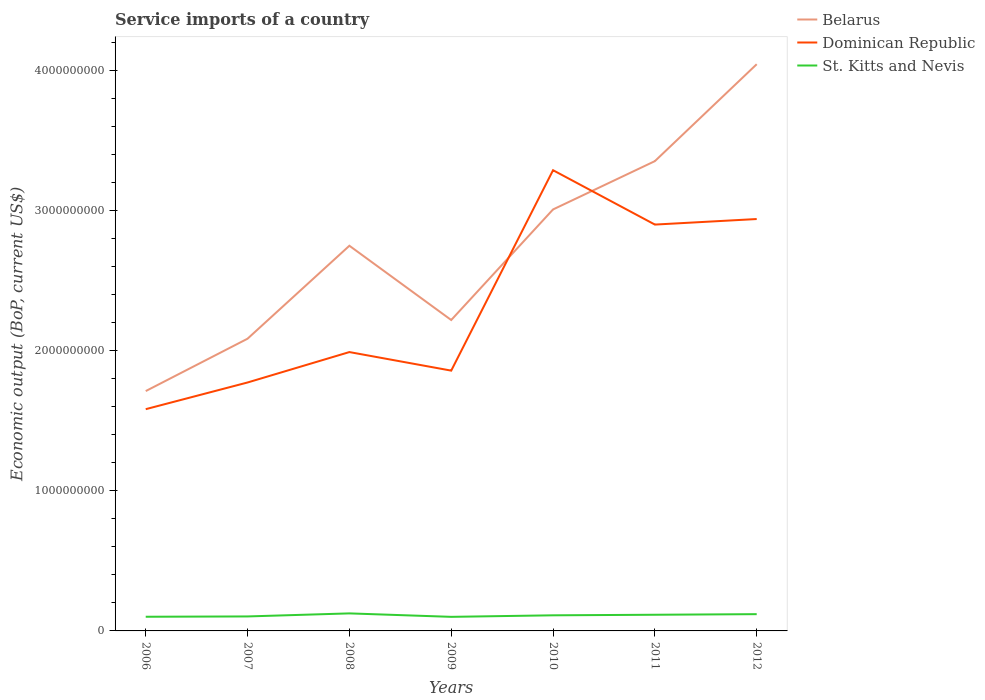How many different coloured lines are there?
Keep it short and to the point. 3. Across all years, what is the maximum service imports in St. Kitts and Nevis?
Your answer should be compact. 1.00e+08. What is the total service imports in St. Kitts and Nevis in the graph?
Ensure brevity in your answer.  -1.85e+07. What is the difference between the highest and the second highest service imports in Belarus?
Your answer should be compact. 2.33e+09. How many lines are there?
Give a very brief answer. 3. How many years are there in the graph?
Your response must be concise. 7. Are the values on the major ticks of Y-axis written in scientific E-notation?
Provide a succinct answer. No. How many legend labels are there?
Ensure brevity in your answer.  3. What is the title of the graph?
Your response must be concise. Service imports of a country. What is the label or title of the X-axis?
Give a very brief answer. Years. What is the label or title of the Y-axis?
Keep it short and to the point. Economic output (BoP, current US$). What is the Economic output (BoP, current US$) of Belarus in 2006?
Make the answer very short. 1.71e+09. What is the Economic output (BoP, current US$) of Dominican Republic in 2006?
Offer a very short reply. 1.58e+09. What is the Economic output (BoP, current US$) in St. Kitts and Nevis in 2006?
Your response must be concise. 1.01e+08. What is the Economic output (BoP, current US$) in Belarus in 2007?
Offer a very short reply. 2.08e+09. What is the Economic output (BoP, current US$) in Dominican Republic in 2007?
Provide a succinct answer. 1.77e+09. What is the Economic output (BoP, current US$) of St. Kitts and Nevis in 2007?
Give a very brief answer. 1.03e+08. What is the Economic output (BoP, current US$) in Belarus in 2008?
Keep it short and to the point. 2.75e+09. What is the Economic output (BoP, current US$) in Dominican Republic in 2008?
Make the answer very short. 1.99e+09. What is the Economic output (BoP, current US$) of St. Kitts and Nevis in 2008?
Ensure brevity in your answer.  1.25e+08. What is the Economic output (BoP, current US$) of Belarus in 2009?
Offer a very short reply. 2.22e+09. What is the Economic output (BoP, current US$) of Dominican Republic in 2009?
Offer a very short reply. 1.86e+09. What is the Economic output (BoP, current US$) in St. Kitts and Nevis in 2009?
Your answer should be compact. 1.00e+08. What is the Economic output (BoP, current US$) in Belarus in 2010?
Provide a short and direct response. 3.01e+09. What is the Economic output (BoP, current US$) in Dominican Republic in 2010?
Your response must be concise. 3.29e+09. What is the Economic output (BoP, current US$) in St. Kitts and Nevis in 2010?
Offer a very short reply. 1.11e+08. What is the Economic output (BoP, current US$) of Belarus in 2011?
Ensure brevity in your answer.  3.35e+09. What is the Economic output (BoP, current US$) of Dominican Republic in 2011?
Offer a very short reply. 2.90e+09. What is the Economic output (BoP, current US$) of St. Kitts and Nevis in 2011?
Your answer should be very brief. 1.15e+08. What is the Economic output (BoP, current US$) in Belarus in 2012?
Provide a succinct answer. 4.04e+09. What is the Economic output (BoP, current US$) in Dominican Republic in 2012?
Make the answer very short. 2.94e+09. What is the Economic output (BoP, current US$) in St. Kitts and Nevis in 2012?
Provide a short and direct response. 1.20e+08. Across all years, what is the maximum Economic output (BoP, current US$) in Belarus?
Your answer should be compact. 4.04e+09. Across all years, what is the maximum Economic output (BoP, current US$) in Dominican Republic?
Your answer should be compact. 3.29e+09. Across all years, what is the maximum Economic output (BoP, current US$) in St. Kitts and Nevis?
Ensure brevity in your answer.  1.25e+08. Across all years, what is the minimum Economic output (BoP, current US$) of Belarus?
Your response must be concise. 1.71e+09. Across all years, what is the minimum Economic output (BoP, current US$) of Dominican Republic?
Ensure brevity in your answer.  1.58e+09. Across all years, what is the minimum Economic output (BoP, current US$) of St. Kitts and Nevis?
Give a very brief answer. 1.00e+08. What is the total Economic output (BoP, current US$) in Belarus in the graph?
Provide a succinct answer. 1.92e+1. What is the total Economic output (BoP, current US$) of Dominican Republic in the graph?
Provide a short and direct response. 1.63e+1. What is the total Economic output (BoP, current US$) of St. Kitts and Nevis in the graph?
Your answer should be very brief. 7.76e+08. What is the difference between the Economic output (BoP, current US$) in Belarus in 2006 and that in 2007?
Offer a terse response. -3.74e+08. What is the difference between the Economic output (BoP, current US$) of Dominican Republic in 2006 and that in 2007?
Your response must be concise. -1.90e+08. What is the difference between the Economic output (BoP, current US$) of St. Kitts and Nevis in 2006 and that in 2007?
Your response must be concise. -2.25e+06. What is the difference between the Economic output (BoP, current US$) of Belarus in 2006 and that in 2008?
Provide a succinct answer. -1.04e+09. What is the difference between the Economic output (BoP, current US$) in Dominican Republic in 2006 and that in 2008?
Ensure brevity in your answer.  -4.07e+08. What is the difference between the Economic output (BoP, current US$) of St. Kitts and Nevis in 2006 and that in 2008?
Your answer should be very brief. -2.40e+07. What is the difference between the Economic output (BoP, current US$) of Belarus in 2006 and that in 2009?
Provide a succinct answer. -5.07e+08. What is the difference between the Economic output (BoP, current US$) in Dominican Republic in 2006 and that in 2009?
Offer a terse response. -2.75e+08. What is the difference between the Economic output (BoP, current US$) of St. Kitts and Nevis in 2006 and that in 2009?
Make the answer very short. 6.64e+05. What is the difference between the Economic output (BoP, current US$) of Belarus in 2006 and that in 2010?
Your answer should be compact. -1.30e+09. What is the difference between the Economic output (BoP, current US$) in Dominican Republic in 2006 and that in 2010?
Your answer should be compact. -1.70e+09. What is the difference between the Economic output (BoP, current US$) in St. Kitts and Nevis in 2006 and that in 2010?
Your response must be concise. -1.03e+07. What is the difference between the Economic output (BoP, current US$) of Belarus in 2006 and that in 2011?
Ensure brevity in your answer.  -1.64e+09. What is the difference between the Economic output (BoP, current US$) of Dominican Republic in 2006 and that in 2011?
Your response must be concise. -1.32e+09. What is the difference between the Economic output (BoP, current US$) of St. Kitts and Nevis in 2006 and that in 2011?
Ensure brevity in your answer.  -1.42e+07. What is the difference between the Economic output (BoP, current US$) in Belarus in 2006 and that in 2012?
Provide a short and direct response. -2.33e+09. What is the difference between the Economic output (BoP, current US$) of Dominican Republic in 2006 and that in 2012?
Offer a very short reply. -1.36e+09. What is the difference between the Economic output (BoP, current US$) in St. Kitts and Nevis in 2006 and that in 2012?
Give a very brief answer. -1.85e+07. What is the difference between the Economic output (BoP, current US$) in Belarus in 2007 and that in 2008?
Your response must be concise. -6.63e+08. What is the difference between the Economic output (BoP, current US$) in Dominican Republic in 2007 and that in 2008?
Your answer should be compact. -2.17e+08. What is the difference between the Economic output (BoP, current US$) of St. Kitts and Nevis in 2007 and that in 2008?
Keep it short and to the point. -2.17e+07. What is the difference between the Economic output (BoP, current US$) of Belarus in 2007 and that in 2009?
Your answer should be compact. -1.33e+08. What is the difference between the Economic output (BoP, current US$) in Dominican Republic in 2007 and that in 2009?
Provide a succinct answer. -8.46e+07. What is the difference between the Economic output (BoP, current US$) of St. Kitts and Nevis in 2007 and that in 2009?
Offer a very short reply. 2.91e+06. What is the difference between the Economic output (BoP, current US$) in Belarus in 2007 and that in 2010?
Ensure brevity in your answer.  -9.22e+08. What is the difference between the Economic output (BoP, current US$) in Dominican Republic in 2007 and that in 2010?
Provide a succinct answer. -1.51e+09. What is the difference between the Economic output (BoP, current US$) in St. Kitts and Nevis in 2007 and that in 2010?
Make the answer very short. -8.01e+06. What is the difference between the Economic output (BoP, current US$) in Belarus in 2007 and that in 2011?
Your answer should be compact. -1.27e+09. What is the difference between the Economic output (BoP, current US$) in Dominican Republic in 2007 and that in 2011?
Keep it short and to the point. -1.13e+09. What is the difference between the Economic output (BoP, current US$) of St. Kitts and Nevis in 2007 and that in 2011?
Ensure brevity in your answer.  -1.20e+07. What is the difference between the Economic output (BoP, current US$) in Belarus in 2007 and that in 2012?
Keep it short and to the point. -1.96e+09. What is the difference between the Economic output (BoP, current US$) of Dominican Republic in 2007 and that in 2012?
Keep it short and to the point. -1.17e+09. What is the difference between the Economic output (BoP, current US$) in St. Kitts and Nevis in 2007 and that in 2012?
Your answer should be compact. -1.62e+07. What is the difference between the Economic output (BoP, current US$) in Belarus in 2008 and that in 2009?
Provide a succinct answer. 5.30e+08. What is the difference between the Economic output (BoP, current US$) of Dominican Republic in 2008 and that in 2009?
Ensure brevity in your answer.  1.32e+08. What is the difference between the Economic output (BoP, current US$) in St. Kitts and Nevis in 2008 and that in 2009?
Your answer should be very brief. 2.46e+07. What is the difference between the Economic output (BoP, current US$) in Belarus in 2008 and that in 2010?
Your answer should be compact. -2.59e+08. What is the difference between the Economic output (BoP, current US$) of Dominican Republic in 2008 and that in 2010?
Offer a terse response. -1.30e+09. What is the difference between the Economic output (BoP, current US$) in St. Kitts and Nevis in 2008 and that in 2010?
Offer a terse response. 1.37e+07. What is the difference between the Economic output (BoP, current US$) of Belarus in 2008 and that in 2011?
Make the answer very short. -6.04e+08. What is the difference between the Economic output (BoP, current US$) in Dominican Republic in 2008 and that in 2011?
Offer a terse response. -9.10e+08. What is the difference between the Economic output (BoP, current US$) of St. Kitts and Nevis in 2008 and that in 2011?
Provide a short and direct response. 9.75e+06. What is the difference between the Economic output (BoP, current US$) of Belarus in 2008 and that in 2012?
Give a very brief answer. -1.30e+09. What is the difference between the Economic output (BoP, current US$) in Dominican Republic in 2008 and that in 2012?
Provide a short and direct response. -9.49e+08. What is the difference between the Economic output (BoP, current US$) in St. Kitts and Nevis in 2008 and that in 2012?
Your answer should be very brief. 5.51e+06. What is the difference between the Economic output (BoP, current US$) in Belarus in 2009 and that in 2010?
Your answer should be compact. -7.89e+08. What is the difference between the Economic output (BoP, current US$) of Dominican Republic in 2009 and that in 2010?
Give a very brief answer. -1.43e+09. What is the difference between the Economic output (BoP, current US$) in St. Kitts and Nevis in 2009 and that in 2010?
Provide a short and direct response. -1.09e+07. What is the difference between the Economic output (BoP, current US$) in Belarus in 2009 and that in 2011?
Provide a succinct answer. -1.13e+09. What is the difference between the Economic output (BoP, current US$) in Dominican Republic in 2009 and that in 2011?
Give a very brief answer. -1.04e+09. What is the difference between the Economic output (BoP, current US$) in St. Kitts and Nevis in 2009 and that in 2011?
Give a very brief answer. -1.49e+07. What is the difference between the Economic output (BoP, current US$) in Belarus in 2009 and that in 2012?
Make the answer very short. -1.83e+09. What is the difference between the Economic output (BoP, current US$) in Dominican Republic in 2009 and that in 2012?
Provide a succinct answer. -1.08e+09. What is the difference between the Economic output (BoP, current US$) of St. Kitts and Nevis in 2009 and that in 2012?
Provide a succinct answer. -1.91e+07. What is the difference between the Economic output (BoP, current US$) of Belarus in 2010 and that in 2011?
Give a very brief answer. -3.45e+08. What is the difference between the Economic output (BoP, current US$) in Dominican Republic in 2010 and that in 2011?
Your response must be concise. 3.88e+08. What is the difference between the Economic output (BoP, current US$) of St. Kitts and Nevis in 2010 and that in 2011?
Make the answer very short. -3.97e+06. What is the difference between the Economic output (BoP, current US$) in Belarus in 2010 and that in 2012?
Offer a very short reply. -1.04e+09. What is the difference between the Economic output (BoP, current US$) in Dominican Republic in 2010 and that in 2012?
Offer a terse response. 3.48e+08. What is the difference between the Economic output (BoP, current US$) of St. Kitts and Nevis in 2010 and that in 2012?
Your answer should be very brief. -8.21e+06. What is the difference between the Economic output (BoP, current US$) in Belarus in 2011 and that in 2012?
Make the answer very short. -6.92e+08. What is the difference between the Economic output (BoP, current US$) of Dominican Republic in 2011 and that in 2012?
Your answer should be very brief. -3.95e+07. What is the difference between the Economic output (BoP, current US$) of St. Kitts and Nevis in 2011 and that in 2012?
Offer a very short reply. -4.23e+06. What is the difference between the Economic output (BoP, current US$) of Belarus in 2006 and the Economic output (BoP, current US$) of Dominican Republic in 2007?
Provide a succinct answer. -6.13e+07. What is the difference between the Economic output (BoP, current US$) of Belarus in 2006 and the Economic output (BoP, current US$) of St. Kitts and Nevis in 2007?
Give a very brief answer. 1.61e+09. What is the difference between the Economic output (BoP, current US$) of Dominican Republic in 2006 and the Economic output (BoP, current US$) of St. Kitts and Nevis in 2007?
Offer a terse response. 1.48e+09. What is the difference between the Economic output (BoP, current US$) of Belarus in 2006 and the Economic output (BoP, current US$) of Dominican Republic in 2008?
Offer a terse response. -2.78e+08. What is the difference between the Economic output (BoP, current US$) of Belarus in 2006 and the Economic output (BoP, current US$) of St. Kitts and Nevis in 2008?
Your response must be concise. 1.59e+09. What is the difference between the Economic output (BoP, current US$) of Dominican Republic in 2006 and the Economic output (BoP, current US$) of St. Kitts and Nevis in 2008?
Make the answer very short. 1.46e+09. What is the difference between the Economic output (BoP, current US$) of Belarus in 2006 and the Economic output (BoP, current US$) of Dominican Republic in 2009?
Offer a very short reply. -1.46e+08. What is the difference between the Economic output (BoP, current US$) in Belarus in 2006 and the Economic output (BoP, current US$) in St. Kitts and Nevis in 2009?
Give a very brief answer. 1.61e+09. What is the difference between the Economic output (BoP, current US$) of Dominican Republic in 2006 and the Economic output (BoP, current US$) of St. Kitts and Nevis in 2009?
Provide a short and direct response. 1.48e+09. What is the difference between the Economic output (BoP, current US$) of Belarus in 2006 and the Economic output (BoP, current US$) of Dominican Republic in 2010?
Provide a succinct answer. -1.58e+09. What is the difference between the Economic output (BoP, current US$) in Belarus in 2006 and the Economic output (BoP, current US$) in St. Kitts and Nevis in 2010?
Keep it short and to the point. 1.60e+09. What is the difference between the Economic output (BoP, current US$) of Dominican Republic in 2006 and the Economic output (BoP, current US$) of St. Kitts and Nevis in 2010?
Provide a succinct answer. 1.47e+09. What is the difference between the Economic output (BoP, current US$) of Belarus in 2006 and the Economic output (BoP, current US$) of Dominican Republic in 2011?
Provide a succinct answer. -1.19e+09. What is the difference between the Economic output (BoP, current US$) in Belarus in 2006 and the Economic output (BoP, current US$) in St. Kitts and Nevis in 2011?
Ensure brevity in your answer.  1.60e+09. What is the difference between the Economic output (BoP, current US$) of Dominican Republic in 2006 and the Economic output (BoP, current US$) of St. Kitts and Nevis in 2011?
Your answer should be very brief. 1.47e+09. What is the difference between the Economic output (BoP, current US$) in Belarus in 2006 and the Economic output (BoP, current US$) in Dominican Republic in 2012?
Make the answer very short. -1.23e+09. What is the difference between the Economic output (BoP, current US$) of Belarus in 2006 and the Economic output (BoP, current US$) of St. Kitts and Nevis in 2012?
Make the answer very short. 1.59e+09. What is the difference between the Economic output (BoP, current US$) in Dominican Republic in 2006 and the Economic output (BoP, current US$) in St. Kitts and Nevis in 2012?
Offer a very short reply. 1.46e+09. What is the difference between the Economic output (BoP, current US$) of Belarus in 2007 and the Economic output (BoP, current US$) of Dominican Republic in 2008?
Offer a terse response. 9.54e+07. What is the difference between the Economic output (BoP, current US$) of Belarus in 2007 and the Economic output (BoP, current US$) of St. Kitts and Nevis in 2008?
Offer a very short reply. 1.96e+09. What is the difference between the Economic output (BoP, current US$) of Dominican Republic in 2007 and the Economic output (BoP, current US$) of St. Kitts and Nevis in 2008?
Your answer should be very brief. 1.65e+09. What is the difference between the Economic output (BoP, current US$) in Belarus in 2007 and the Economic output (BoP, current US$) in Dominican Republic in 2009?
Your answer should be compact. 2.28e+08. What is the difference between the Economic output (BoP, current US$) of Belarus in 2007 and the Economic output (BoP, current US$) of St. Kitts and Nevis in 2009?
Offer a very short reply. 1.98e+09. What is the difference between the Economic output (BoP, current US$) of Dominican Republic in 2007 and the Economic output (BoP, current US$) of St. Kitts and Nevis in 2009?
Ensure brevity in your answer.  1.67e+09. What is the difference between the Economic output (BoP, current US$) in Belarus in 2007 and the Economic output (BoP, current US$) in Dominican Republic in 2010?
Ensure brevity in your answer.  -1.20e+09. What is the difference between the Economic output (BoP, current US$) of Belarus in 2007 and the Economic output (BoP, current US$) of St. Kitts and Nevis in 2010?
Your answer should be very brief. 1.97e+09. What is the difference between the Economic output (BoP, current US$) of Dominican Republic in 2007 and the Economic output (BoP, current US$) of St. Kitts and Nevis in 2010?
Offer a terse response. 1.66e+09. What is the difference between the Economic output (BoP, current US$) of Belarus in 2007 and the Economic output (BoP, current US$) of Dominican Republic in 2011?
Ensure brevity in your answer.  -8.14e+08. What is the difference between the Economic output (BoP, current US$) of Belarus in 2007 and the Economic output (BoP, current US$) of St. Kitts and Nevis in 2011?
Your answer should be compact. 1.97e+09. What is the difference between the Economic output (BoP, current US$) in Dominican Republic in 2007 and the Economic output (BoP, current US$) in St. Kitts and Nevis in 2011?
Ensure brevity in your answer.  1.66e+09. What is the difference between the Economic output (BoP, current US$) in Belarus in 2007 and the Economic output (BoP, current US$) in Dominican Republic in 2012?
Provide a short and direct response. -8.54e+08. What is the difference between the Economic output (BoP, current US$) in Belarus in 2007 and the Economic output (BoP, current US$) in St. Kitts and Nevis in 2012?
Offer a very short reply. 1.97e+09. What is the difference between the Economic output (BoP, current US$) of Dominican Republic in 2007 and the Economic output (BoP, current US$) of St. Kitts and Nevis in 2012?
Provide a short and direct response. 1.65e+09. What is the difference between the Economic output (BoP, current US$) of Belarus in 2008 and the Economic output (BoP, current US$) of Dominican Republic in 2009?
Offer a very short reply. 8.91e+08. What is the difference between the Economic output (BoP, current US$) of Belarus in 2008 and the Economic output (BoP, current US$) of St. Kitts and Nevis in 2009?
Offer a very short reply. 2.65e+09. What is the difference between the Economic output (BoP, current US$) in Dominican Republic in 2008 and the Economic output (BoP, current US$) in St. Kitts and Nevis in 2009?
Your response must be concise. 1.89e+09. What is the difference between the Economic output (BoP, current US$) of Belarus in 2008 and the Economic output (BoP, current US$) of Dominican Republic in 2010?
Offer a very short reply. -5.39e+08. What is the difference between the Economic output (BoP, current US$) in Belarus in 2008 and the Economic output (BoP, current US$) in St. Kitts and Nevis in 2010?
Provide a short and direct response. 2.64e+09. What is the difference between the Economic output (BoP, current US$) of Dominican Republic in 2008 and the Economic output (BoP, current US$) of St. Kitts and Nevis in 2010?
Ensure brevity in your answer.  1.88e+09. What is the difference between the Economic output (BoP, current US$) of Belarus in 2008 and the Economic output (BoP, current US$) of Dominican Republic in 2011?
Make the answer very short. -1.51e+08. What is the difference between the Economic output (BoP, current US$) of Belarus in 2008 and the Economic output (BoP, current US$) of St. Kitts and Nevis in 2011?
Provide a succinct answer. 2.63e+09. What is the difference between the Economic output (BoP, current US$) of Dominican Republic in 2008 and the Economic output (BoP, current US$) of St. Kitts and Nevis in 2011?
Provide a succinct answer. 1.87e+09. What is the difference between the Economic output (BoP, current US$) of Belarus in 2008 and the Economic output (BoP, current US$) of Dominican Republic in 2012?
Offer a very short reply. -1.90e+08. What is the difference between the Economic output (BoP, current US$) of Belarus in 2008 and the Economic output (BoP, current US$) of St. Kitts and Nevis in 2012?
Ensure brevity in your answer.  2.63e+09. What is the difference between the Economic output (BoP, current US$) in Dominican Republic in 2008 and the Economic output (BoP, current US$) in St. Kitts and Nevis in 2012?
Offer a terse response. 1.87e+09. What is the difference between the Economic output (BoP, current US$) in Belarus in 2009 and the Economic output (BoP, current US$) in Dominican Republic in 2010?
Offer a terse response. -1.07e+09. What is the difference between the Economic output (BoP, current US$) of Belarus in 2009 and the Economic output (BoP, current US$) of St. Kitts and Nevis in 2010?
Your answer should be compact. 2.11e+09. What is the difference between the Economic output (BoP, current US$) in Dominican Republic in 2009 and the Economic output (BoP, current US$) in St. Kitts and Nevis in 2010?
Ensure brevity in your answer.  1.75e+09. What is the difference between the Economic output (BoP, current US$) of Belarus in 2009 and the Economic output (BoP, current US$) of Dominican Republic in 2011?
Give a very brief answer. -6.81e+08. What is the difference between the Economic output (BoP, current US$) of Belarus in 2009 and the Economic output (BoP, current US$) of St. Kitts and Nevis in 2011?
Your response must be concise. 2.10e+09. What is the difference between the Economic output (BoP, current US$) in Dominican Republic in 2009 and the Economic output (BoP, current US$) in St. Kitts and Nevis in 2011?
Provide a succinct answer. 1.74e+09. What is the difference between the Economic output (BoP, current US$) of Belarus in 2009 and the Economic output (BoP, current US$) of Dominican Republic in 2012?
Provide a short and direct response. -7.20e+08. What is the difference between the Economic output (BoP, current US$) of Belarus in 2009 and the Economic output (BoP, current US$) of St. Kitts and Nevis in 2012?
Your response must be concise. 2.10e+09. What is the difference between the Economic output (BoP, current US$) in Dominican Republic in 2009 and the Economic output (BoP, current US$) in St. Kitts and Nevis in 2012?
Offer a terse response. 1.74e+09. What is the difference between the Economic output (BoP, current US$) of Belarus in 2010 and the Economic output (BoP, current US$) of Dominican Republic in 2011?
Make the answer very short. 1.08e+08. What is the difference between the Economic output (BoP, current US$) of Belarus in 2010 and the Economic output (BoP, current US$) of St. Kitts and Nevis in 2011?
Offer a terse response. 2.89e+09. What is the difference between the Economic output (BoP, current US$) of Dominican Republic in 2010 and the Economic output (BoP, current US$) of St. Kitts and Nevis in 2011?
Make the answer very short. 3.17e+09. What is the difference between the Economic output (BoP, current US$) of Belarus in 2010 and the Economic output (BoP, current US$) of Dominican Republic in 2012?
Your response must be concise. 6.85e+07. What is the difference between the Economic output (BoP, current US$) in Belarus in 2010 and the Economic output (BoP, current US$) in St. Kitts and Nevis in 2012?
Your answer should be very brief. 2.89e+09. What is the difference between the Economic output (BoP, current US$) of Dominican Republic in 2010 and the Economic output (BoP, current US$) of St. Kitts and Nevis in 2012?
Your answer should be very brief. 3.17e+09. What is the difference between the Economic output (BoP, current US$) of Belarus in 2011 and the Economic output (BoP, current US$) of Dominican Republic in 2012?
Your answer should be compact. 4.13e+08. What is the difference between the Economic output (BoP, current US$) in Belarus in 2011 and the Economic output (BoP, current US$) in St. Kitts and Nevis in 2012?
Your response must be concise. 3.23e+09. What is the difference between the Economic output (BoP, current US$) in Dominican Republic in 2011 and the Economic output (BoP, current US$) in St. Kitts and Nevis in 2012?
Ensure brevity in your answer.  2.78e+09. What is the average Economic output (BoP, current US$) of Belarus per year?
Provide a succinct answer. 2.74e+09. What is the average Economic output (BoP, current US$) of Dominican Republic per year?
Your response must be concise. 2.33e+09. What is the average Economic output (BoP, current US$) of St. Kitts and Nevis per year?
Provide a short and direct response. 1.11e+08. In the year 2006, what is the difference between the Economic output (BoP, current US$) of Belarus and Economic output (BoP, current US$) of Dominican Republic?
Your response must be concise. 1.29e+08. In the year 2006, what is the difference between the Economic output (BoP, current US$) in Belarus and Economic output (BoP, current US$) in St. Kitts and Nevis?
Offer a very short reply. 1.61e+09. In the year 2006, what is the difference between the Economic output (BoP, current US$) in Dominican Republic and Economic output (BoP, current US$) in St. Kitts and Nevis?
Offer a terse response. 1.48e+09. In the year 2007, what is the difference between the Economic output (BoP, current US$) of Belarus and Economic output (BoP, current US$) of Dominican Republic?
Give a very brief answer. 3.12e+08. In the year 2007, what is the difference between the Economic output (BoP, current US$) in Belarus and Economic output (BoP, current US$) in St. Kitts and Nevis?
Provide a succinct answer. 1.98e+09. In the year 2007, what is the difference between the Economic output (BoP, current US$) of Dominican Republic and Economic output (BoP, current US$) of St. Kitts and Nevis?
Offer a terse response. 1.67e+09. In the year 2008, what is the difference between the Economic output (BoP, current US$) of Belarus and Economic output (BoP, current US$) of Dominican Republic?
Keep it short and to the point. 7.59e+08. In the year 2008, what is the difference between the Economic output (BoP, current US$) of Belarus and Economic output (BoP, current US$) of St. Kitts and Nevis?
Make the answer very short. 2.62e+09. In the year 2008, what is the difference between the Economic output (BoP, current US$) of Dominican Republic and Economic output (BoP, current US$) of St. Kitts and Nevis?
Offer a terse response. 1.86e+09. In the year 2009, what is the difference between the Economic output (BoP, current US$) in Belarus and Economic output (BoP, current US$) in Dominican Republic?
Offer a very short reply. 3.61e+08. In the year 2009, what is the difference between the Economic output (BoP, current US$) of Belarus and Economic output (BoP, current US$) of St. Kitts and Nevis?
Offer a very short reply. 2.12e+09. In the year 2009, what is the difference between the Economic output (BoP, current US$) of Dominican Republic and Economic output (BoP, current US$) of St. Kitts and Nevis?
Provide a short and direct response. 1.76e+09. In the year 2010, what is the difference between the Economic output (BoP, current US$) in Belarus and Economic output (BoP, current US$) in Dominican Republic?
Provide a short and direct response. -2.80e+08. In the year 2010, what is the difference between the Economic output (BoP, current US$) of Belarus and Economic output (BoP, current US$) of St. Kitts and Nevis?
Your answer should be compact. 2.90e+09. In the year 2010, what is the difference between the Economic output (BoP, current US$) in Dominican Republic and Economic output (BoP, current US$) in St. Kitts and Nevis?
Keep it short and to the point. 3.18e+09. In the year 2011, what is the difference between the Economic output (BoP, current US$) in Belarus and Economic output (BoP, current US$) in Dominican Republic?
Provide a short and direct response. 4.53e+08. In the year 2011, what is the difference between the Economic output (BoP, current US$) of Belarus and Economic output (BoP, current US$) of St. Kitts and Nevis?
Provide a short and direct response. 3.24e+09. In the year 2011, what is the difference between the Economic output (BoP, current US$) in Dominican Republic and Economic output (BoP, current US$) in St. Kitts and Nevis?
Give a very brief answer. 2.78e+09. In the year 2012, what is the difference between the Economic output (BoP, current US$) of Belarus and Economic output (BoP, current US$) of Dominican Republic?
Keep it short and to the point. 1.10e+09. In the year 2012, what is the difference between the Economic output (BoP, current US$) of Belarus and Economic output (BoP, current US$) of St. Kitts and Nevis?
Provide a short and direct response. 3.92e+09. In the year 2012, what is the difference between the Economic output (BoP, current US$) in Dominican Republic and Economic output (BoP, current US$) in St. Kitts and Nevis?
Make the answer very short. 2.82e+09. What is the ratio of the Economic output (BoP, current US$) in Belarus in 2006 to that in 2007?
Your answer should be compact. 0.82. What is the ratio of the Economic output (BoP, current US$) in Dominican Republic in 2006 to that in 2007?
Your response must be concise. 0.89. What is the ratio of the Economic output (BoP, current US$) in St. Kitts and Nevis in 2006 to that in 2007?
Your response must be concise. 0.98. What is the ratio of the Economic output (BoP, current US$) of Belarus in 2006 to that in 2008?
Ensure brevity in your answer.  0.62. What is the ratio of the Economic output (BoP, current US$) of Dominican Republic in 2006 to that in 2008?
Your answer should be compact. 0.8. What is the ratio of the Economic output (BoP, current US$) in St. Kitts and Nevis in 2006 to that in 2008?
Your response must be concise. 0.81. What is the ratio of the Economic output (BoP, current US$) of Belarus in 2006 to that in 2009?
Your answer should be compact. 0.77. What is the ratio of the Economic output (BoP, current US$) in Dominican Republic in 2006 to that in 2009?
Your answer should be very brief. 0.85. What is the ratio of the Economic output (BoP, current US$) of St. Kitts and Nevis in 2006 to that in 2009?
Give a very brief answer. 1.01. What is the ratio of the Economic output (BoP, current US$) of Belarus in 2006 to that in 2010?
Offer a very short reply. 0.57. What is the ratio of the Economic output (BoP, current US$) in Dominican Republic in 2006 to that in 2010?
Provide a succinct answer. 0.48. What is the ratio of the Economic output (BoP, current US$) of St. Kitts and Nevis in 2006 to that in 2010?
Provide a short and direct response. 0.91. What is the ratio of the Economic output (BoP, current US$) of Belarus in 2006 to that in 2011?
Offer a terse response. 0.51. What is the ratio of the Economic output (BoP, current US$) in Dominican Republic in 2006 to that in 2011?
Your answer should be very brief. 0.55. What is the ratio of the Economic output (BoP, current US$) in St. Kitts and Nevis in 2006 to that in 2011?
Make the answer very short. 0.88. What is the ratio of the Economic output (BoP, current US$) of Belarus in 2006 to that in 2012?
Keep it short and to the point. 0.42. What is the ratio of the Economic output (BoP, current US$) in Dominican Republic in 2006 to that in 2012?
Make the answer very short. 0.54. What is the ratio of the Economic output (BoP, current US$) in St. Kitts and Nevis in 2006 to that in 2012?
Your answer should be compact. 0.85. What is the ratio of the Economic output (BoP, current US$) of Belarus in 2007 to that in 2008?
Provide a short and direct response. 0.76. What is the ratio of the Economic output (BoP, current US$) of Dominican Republic in 2007 to that in 2008?
Make the answer very short. 0.89. What is the ratio of the Economic output (BoP, current US$) of St. Kitts and Nevis in 2007 to that in 2008?
Your answer should be compact. 0.83. What is the ratio of the Economic output (BoP, current US$) in Belarus in 2007 to that in 2009?
Offer a very short reply. 0.94. What is the ratio of the Economic output (BoP, current US$) of Dominican Republic in 2007 to that in 2009?
Make the answer very short. 0.95. What is the ratio of the Economic output (BoP, current US$) of St. Kitts and Nevis in 2007 to that in 2009?
Give a very brief answer. 1.03. What is the ratio of the Economic output (BoP, current US$) in Belarus in 2007 to that in 2010?
Your answer should be very brief. 0.69. What is the ratio of the Economic output (BoP, current US$) in Dominican Republic in 2007 to that in 2010?
Your response must be concise. 0.54. What is the ratio of the Economic output (BoP, current US$) of St. Kitts and Nevis in 2007 to that in 2010?
Ensure brevity in your answer.  0.93. What is the ratio of the Economic output (BoP, current US$) in Belarus in 2007 to that in 2011?
Ensure brevity in your answer.  0.62. What is the ratio of the Economic output (BoP, current US$) in Dominican Republic in 2007 to that in 2011?
Keep it short and to the point. 0.61. What is the ratio of the Economic output (BoP, current US$) in St. Kitts and Nevis in 2007 to that in 2011?
Your answer should be compact. 0.9. What is the ratio of the Economic output (BoP, current US$) in Belarus in 2007 to that in 2012?
Ensure brevity in your answer.  0.52. What is the ratio of the Economic output (BoP, current US$) in Dominican Republic in 2007 to that in 2012?
Your response must be concise. 0.6. What is the ratio of the Economic output (BoP, current US$) in St. Kitts and Nevis in 2007 to that in 2012?
Provide a succinct answer. 0.86. What is the ratio of the Economic output (BoP, current US$) of Belarus in 2008 to that in 2009?
Your response must be concise. 1.24. What is the ratio of the Economic output (BoP, current US$) in Dominican Republic in 2008 to that in 2009?
Your answer should be very brief. 1.07. What is the ratio of the Economic output (BoP, current US$) of St. Kitts and Nevis in 2008 to that in 2009?
Give a very brief answer. 1.25. What is the ratio of the Economic output (BoP, current US$) of Belarus in 2008 to that in 2010?
Offer a very short reply. 0.91. What is the ratio of the Economic output (BoP, current US$) of Dominican Republic in 2008 to that in 2010?
Your answer should be very brief. 0.61. What is the ratio of the Economic output (BoP, current US$) of St. Kitts and Nevis in 2008 to that in 2010?
Provide a short and direct response. 1.12. What is the ratio of the Economic output (BoP, current US$) of Belarus in 2008 to that in 2011?
Offer a terse response. 0.82. What is the ratio of the Economic output (BoP, current US$) in Dominican Republic in 2008 to that in 2011?
Give a very brief answer. 0.69. What is the ratio of the Economic output (BoP, current US$) in St. Kitts and Nevis in 2008 to that in 2011?
Offer a terse response. 1.08. What is the ratio of the Economic output (BoP, current US$) of Belarus in 2008 to that in 2012?
Make the answer very short. 0.68. What is the ratio of the Economic output (BoP, current US$) in Dominican Republic in 2008 to that in 2012?
Your answer should be compact. 0.68. What is the ratio of the Economic output (BoP, current US$) of St. Kitts and Nevis in 2008 to that in 2012?
Provide a short and direct response. 1.05. What is the ratio of the Economic output (BoP, current US$) of Belarus in 2009 to that in 2010?
Keep it short and to the point. 0.74. What is the ratio of the Economic output (BoP, current US$) of Dominican Republic in 2009 to that in 2010?
Your answer should be compact. 0.56. What is the ratio of the Economic output (BoP, current US$) of St. Kitts and Nevis in 2009 to that in 2010?
Keep it short and to the point. 0.9. What is the ratio of the Economic output (BoP, current US$) of Belarus in 2009 to that in 2011?
Provide a short and direct response. 0.66. What is the ratio of the Economic output (BoP, current US$) of Dominican Republic in 2009 to that in 2011?
Provide a short and direct response. 0.64. What is the ratio of the Economic output (BoP, current US$) in St. Kitts and Nevis in 2009 to that in 2011?
Your response must be concise. 0.87. What is the ratio of the Economic output (BoP, current US$) of Belarus in 2009 to that in 2012?
Keep it short and to the point. 0.55. What is the ratio of the Economic output (BoP, current US$) of Dominican Republic in 2009 to that in 2012?
Your response must be concise. 0.63. What is the ratio of the Economic output (BoP, current US$) of St. Kitts and Nevis in 2009 to that in 2012?
Offer a terse response. 0.84. What is the ratio of the Economic output (BoP, current US$) in Belarus in 2010 to that in 2011?
Your response must be concise. 0.9. What is the ratio of the Economic output (BoP, current US$) of Dominican Republic in 2010 to that in 2011?
Make the answer very short. 1.13. What is the ratio of the Economic output (BoP, current US$) of St. Kitts and Nevis in 2010 to that in 2011?
Provide a succinct answer. 0.97. What is the ratio of the Economic output (BoP, current US$) of Belarus in 2010 to that in 2012?
Your response must be concise. 0.74. What is the ratio of the Economic output (BoP, current US$) of Dominican Republic in 2010 to that in 2012?
Your answer should be compact. 1.12. What is the ratio of the Economic output (BoP, current US$) of St. Kitts and Nevis in 2010 to that in 2012?
Give a very brief answer. 0.93. What is the ratio of the Economic output (BoP, current US$) of Belarus in 2011 to that in 2012?
Your response must be concise. 0.83. What is the ratio of the Economic output (BoP, current US$) in Dominican Republic in 2011 to that in 2012?
Your answer should be compact. 0.99. What is the ratio of the Economic output (BoP, current US$) of St. Kitts and Nevis in 2011 to that in 2012?
Ensure brevity in your answer.  0.96. What is the difference between the highest and the second highest Economic output (BoP, current US$) of Belarus?
Your answer should be compact. 6.92e+08. What is the difference between the highest and the second highest Economic output (BoP, current US$) in Dominican Republic?
Offer a terse response. 3.48e+08. What is the difference between the highest and the second highest Economic output (BoP, current US$) in St. Kitts and Nevis?
Make the answer very short. 5.51e+06. What is the difference between the highest and the lowest Economic output (BoP, current US$) in Belarus?
Your answer should be very brief. 2.33e+09. What is the difference between the highest and the lowest Economic output (BoP, current US$) of Dominican Republic?
Provide a succinct answer. 1.70e+09. What is the difference between the highest and the lowest Economic output (BoP, current US$) in St. Kitts and Nevis?
Offer a very short reply. 2.46e+07. 